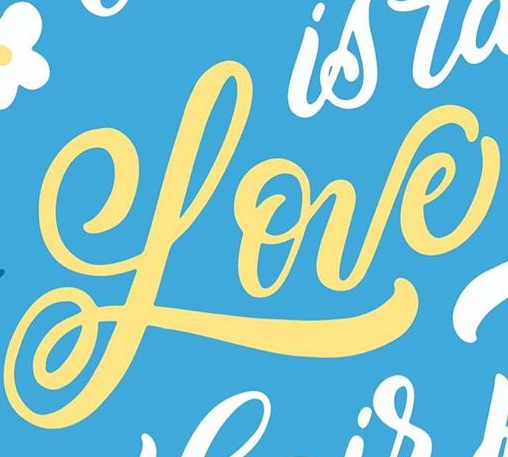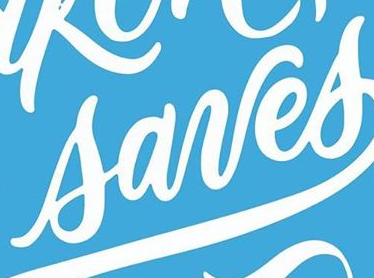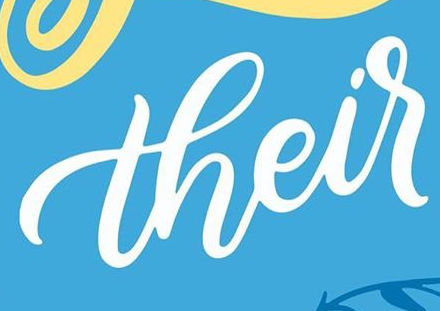What text is displayed in these images sequentially, separated by a semicolon? Love; sanes; their 